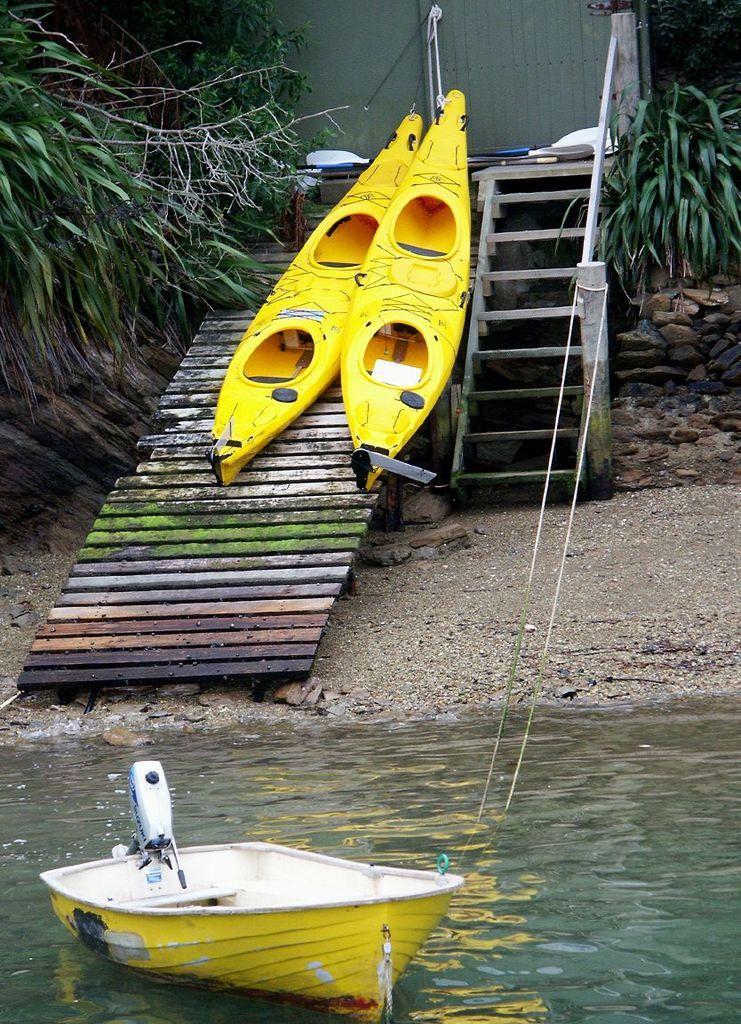How would you summarize this image in a sentence or two? In front of the image there is a boat in the water. There are two boats on the pavement. There are stairs, plants, rocks. There are some objects on the table. In the background of the image there is a wall. 